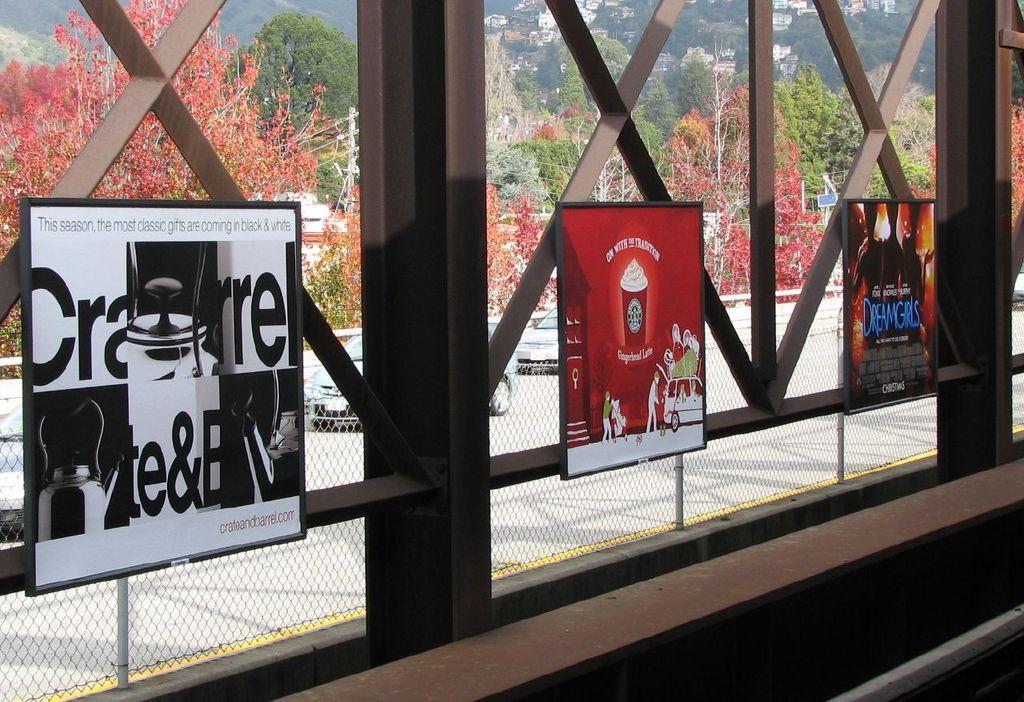Describe this image in one or two sentences. In this image I can see boards, fence, metal rods, trees, mountains and houses. This image is taken may be during a sunny day. 